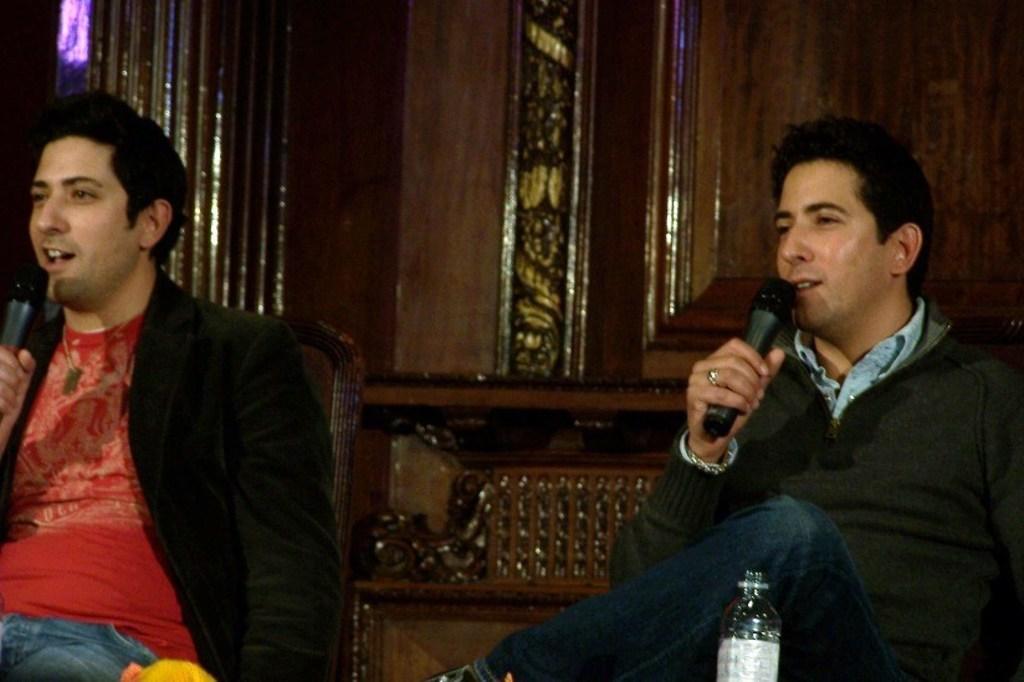Could you give a brief overview of what you see in this image? In this image we can see two men sitting on the chairs holding the mikes. In the foreground we can see a bottle. On the backside we can see the wooden surface. 